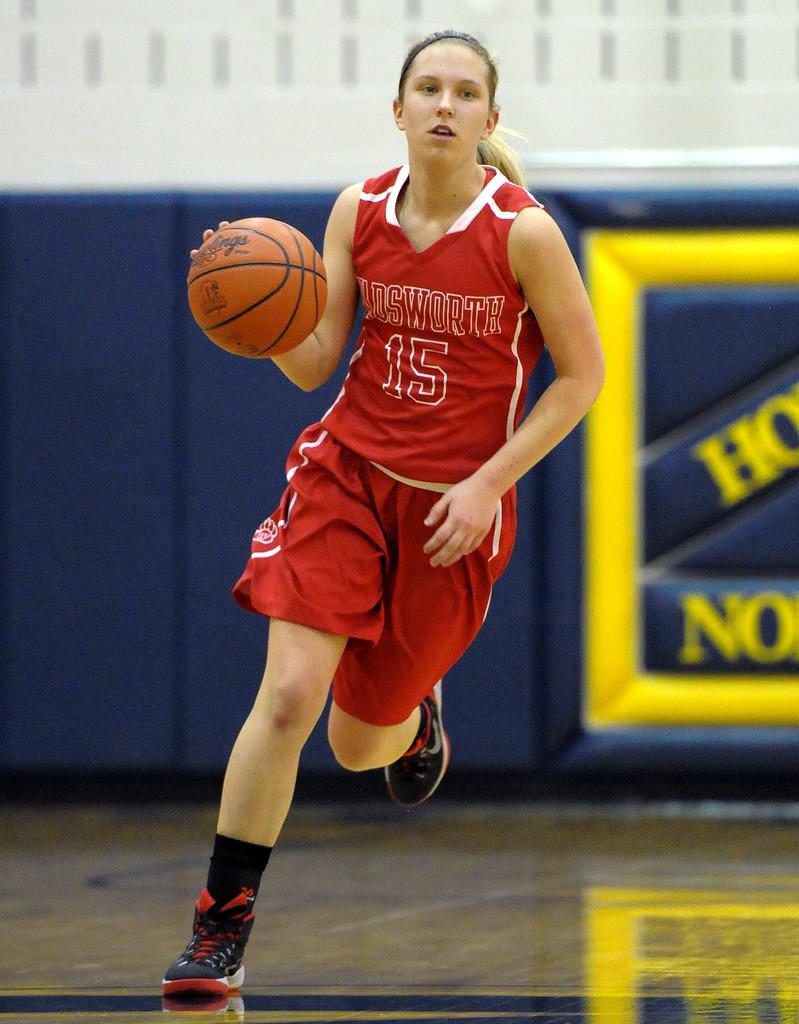<image>
Present a compact description of the photo's key features. Basketball player wearing number 15 dribbling the ball. 